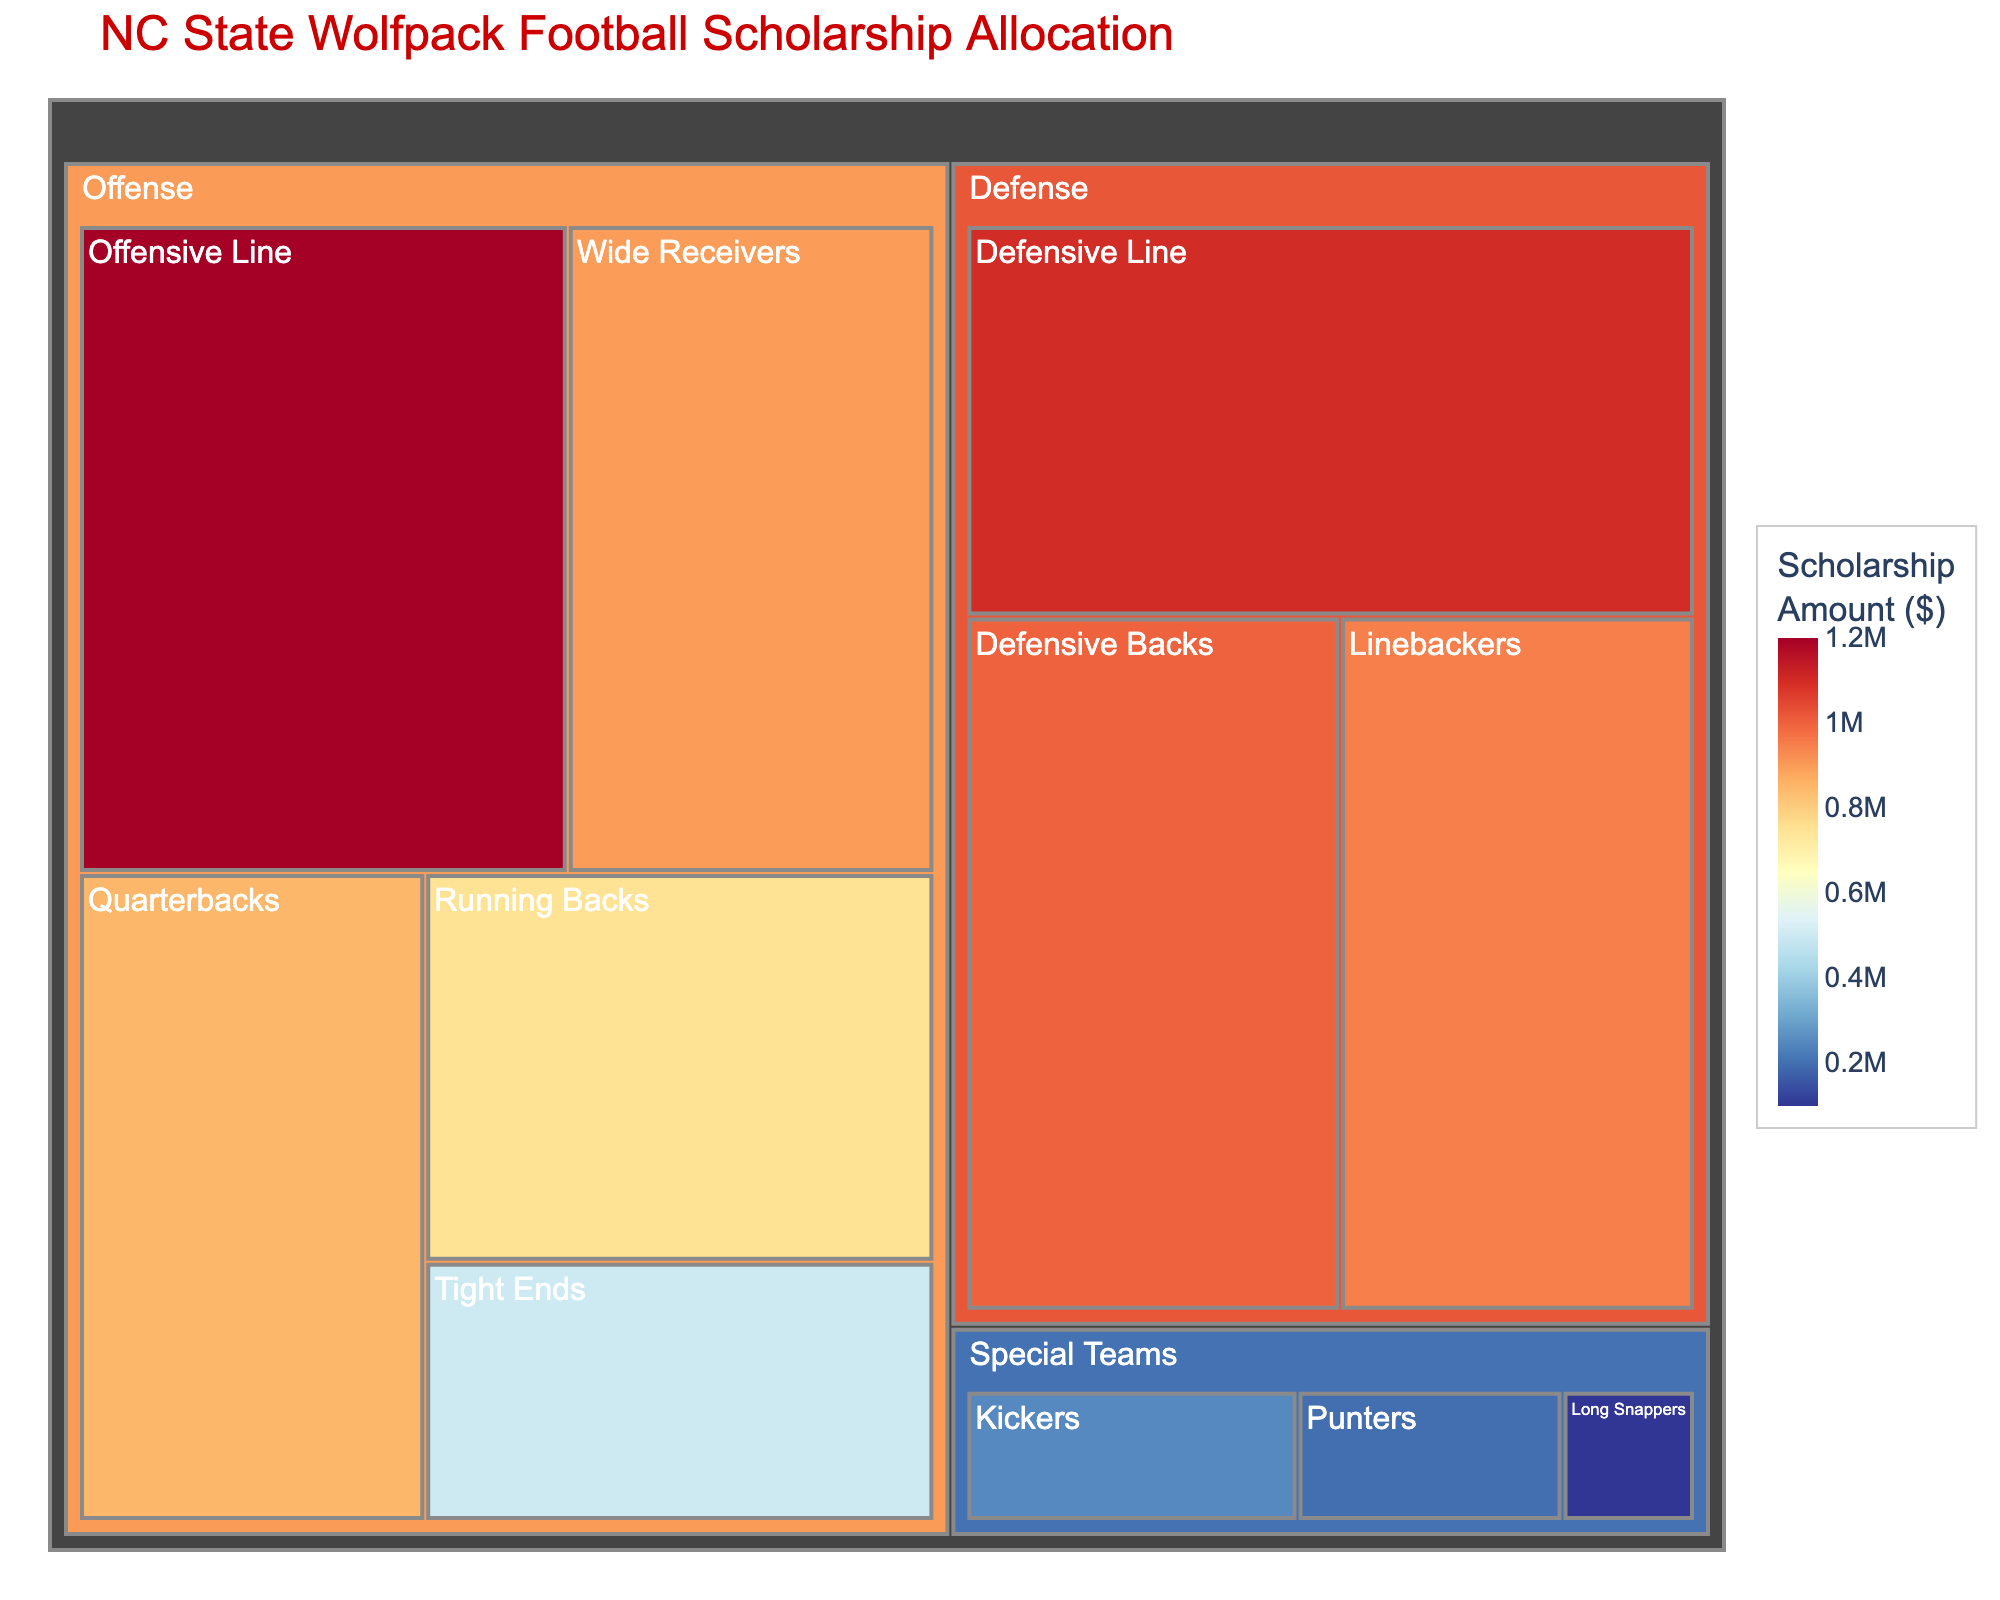What is the title of the treemap? The title is usually placed at the top of the plot and provides a brief description of what the figure is about.
Answer: NC State Wolfpack Football Scholarship Allocation Which position group receives the highest scholarship allocation? By looking at the largest and most prominently colored area in the treemap, we can identify the position group with the highest scholarship funding.
Answer: Offensive Line What's the scholarship amount allocated to Special Teams? Sum the scholarship amounts of Kickers, Punters, and Long Snappers, which belong to Special Teams. $250,000 + $200,000 + $100,000 = $550,000
Answer: $550,000 Compare the scholarship amounts for Quarterbacks and Linebackers. Which group receives more? Look at the allocation amounts for Quarterbacks and Linebackers in the treemap. Quarterbacks receive $850,000, while Linebackers get $950,000.
Answer: Linebackers What is the total scholarship amount for offensive position groups? Sum the scholarship amounts for all offensive subgroups: $850,000 (Quarterbacks) + $750,000 (Running Backs) + $900,000 (Wide Receivers) + $500,000 (Tight Ends) + $1,200,000 (Offensive Line) = $4,200,000
Answer: $4,200,000 Which position group under Defense has the smaller allocation, Defensive Line or Defensive Backs? Compare the scholarship amounts for the Defensive Line ($1,100,000) and Defensive Backs ($1,000,000) by looking at their respective blocks in the treemap.
Answer: Defensive Backs What is the average scholarship amount across all subgroups? First, calculate the total of all scholarship amounts: $8,300,000. Then divide by the number of subgroups (10). $8,300,000 / 10 = $830,000
Answer: $830,000 Which of the subgroups within Special Teams receives the smallest scholarship allocation? Look at the subgroups within Special Teams and compare their allocation amounts. The amounts are $250,000 (Kickers), $200,000 (Punters), and $100,000 (Long Snappers).
Answer: Long Snappers What is the combined scholarship amount for Defensive Line and Offensive Line? Add the scholarship amounts for both Defensive Line and Offensive Line: $1,100,000 (Defensive Line) + $1,200,000 (Offensive Line) = $2,300,000
Answer: $2,300,000 How much more does the Wide Receivers subgroup receive compared to Tight Ends? Subtract the scholarship amount for Tight Ends from that for Wide Receivers: $900,000 (Wide Receivers) - $500,000 (Tight Ends) = $400,000
Answer: $400,000 